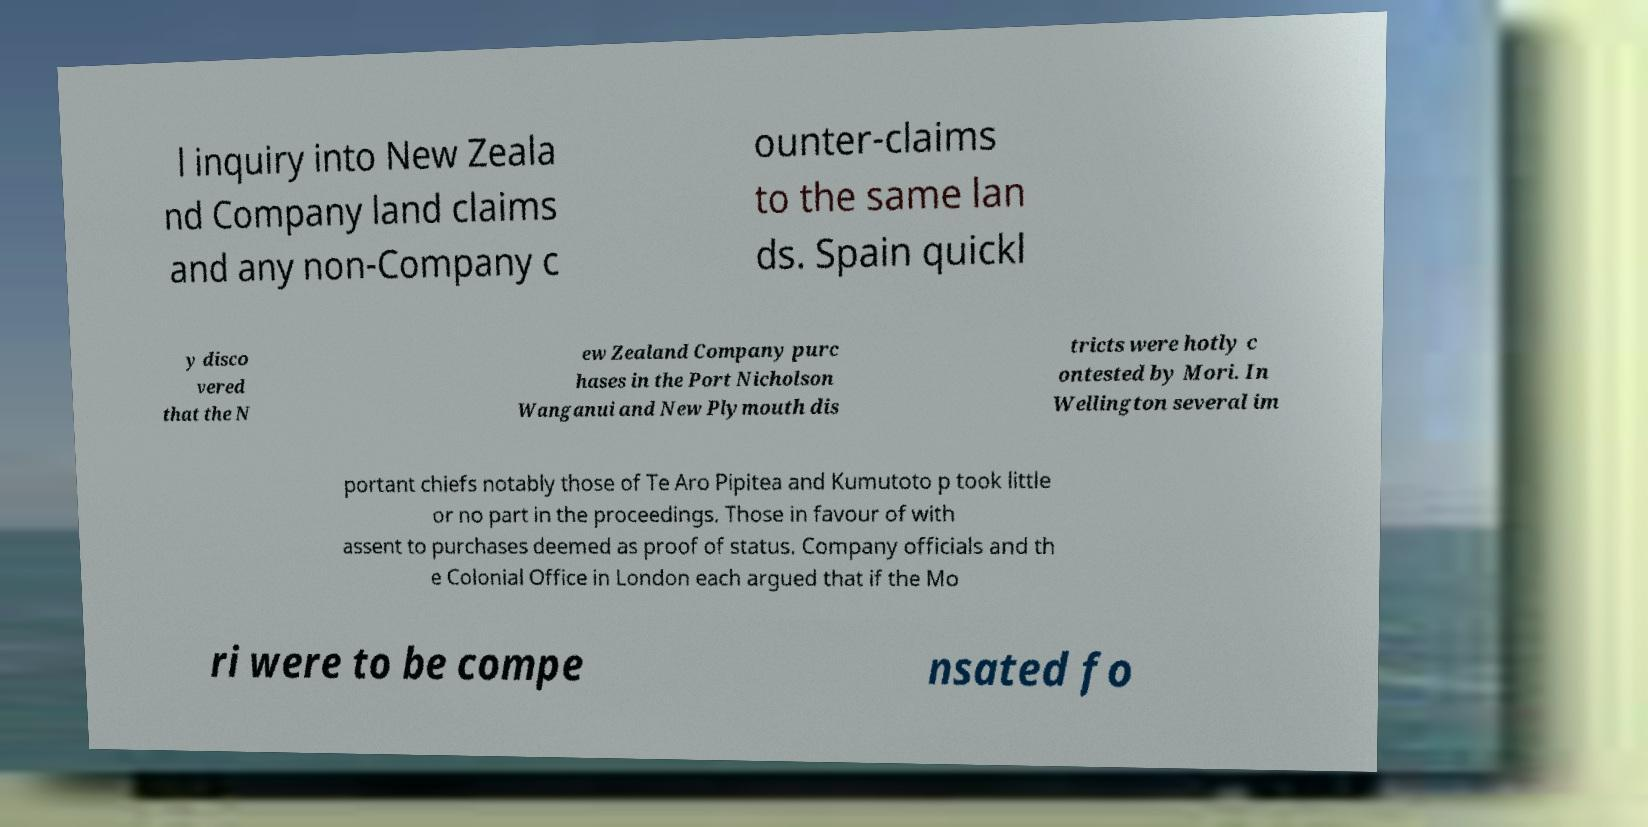Can you accurately transcribe the text from the provided image for me? l inquiry into New Zeala nd Company land claims and any non-Company c ounter-claims to the same lan ds. Spain quickl y disco vered that the N ew Zealand Company purc hases in the Port Nicholson Wanganui and New Plymouth dis tricts were hotly c ontested by Mori. In Wellington several im portant chiefs notably those of Te Aro Pipitea and Kumutoto p took little or no part in the proceedings. Those in favour of with assent to purchases deemed as proof of status. Company officials and th e Colonial Office in London each argued that if the Mo ri were to be compe nsated fo 